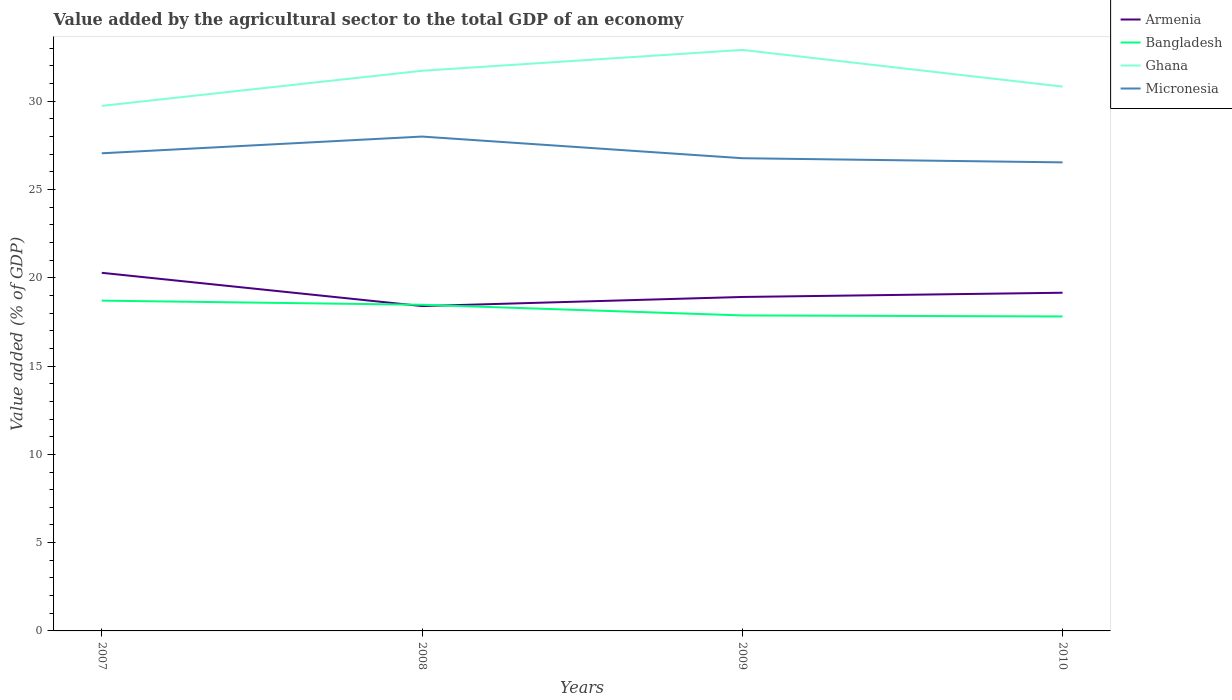How many different coloured lines are there?
Offer a very short reply. 4. Does the line corresponding to Armenia intersect with the line corresponding to Ghana?
Your answer should be compact. No. Across all years, what is the maximum value added by the agricultural sector to the total GDP in Micronesia?
Make the answer very short. 26.54. What is the total value added by the agricultural sector to the total GDP in Bangladesh in the graph?
Provide a succinct answer. 0.84. What is the difference between the highest and the second highest value added by the agricultural sector to the total GDP in Bangladesh?
Your answer should be compact. 0.9. What is the difference between the highest and the lowest value added by the agricultural sector to the total GDP in Armenia?
Keep it short and to the point. 1. Is the value added by the agricultural sector to the total GDP in Ghana strictly greater than the value added by the agricultural sector to the total GDP in Armenia over the years?
Provide a succinct answer. No. Are the values on the major ticks of Y-axis written in scientific E-notation?
Give a very brief answer. No. Where does the legend appear in the graph?
Offer a terse response. Top right. How many legend labels are there?
Ensure brevity in your answer.  4. How are the legend labels stacked?
Keep it short and to the point. Vertical. What is the title of the graph?
Keep it short and to the point. Value added by the agricultural sector to the total GDP of an economy. Does "Guinea-Bissau" appear as one of the legend labels in the graph?
Keep it short and to the point. No. What is the label or title of the X-axis?
Your response must be concise. Years. What is the label or title of the Y-axis?
Your response must be concise. Value added (% of GDP). What is the Value added (% of GDP) in Armenia in 2007?
Keep it short and to the point. 20.28. What is the Value added (% of GDP) of Bangladesh in 2007?
Provide a succinct answer. 18.71. What is the Value added (% of GDP) of Ghana in 2007?
Your answer should be very brief. 29.74. What is the Value added (% of GDP) of Micronesia in 2007?
Your response must be concise. 27.05. What is the Value added (% of GDP) of Armenia in 2008?
Your response must be concise. 18.4. What is the Value added (% of GDP) of Bangladesh in 2008?
Offer a terse response. 18.47. What is the Value added (% of GDP) in Ghana in 2008?
Your response must be concise. 31.72. What is the Value added (% of GDP) in Micronesia in 2008?
Give a very brief answer. 28. What is the Value added (% of GDP) of Armenia in 2009?
Ensure brevity in your answer.  18.91. What is the Value added (% of GDP) in Bangladesh in 2009?
Keep it short and to the point. 17.87. What is the Value added (% of GDP) of Ghana in 2009?
Offer a very short reply. 32.91. What is the Value added (% of GDP) in Micronesia in 2009?
Your answer should be very brief. 26.77. What is the Value added (% of GDP) of Armenia in 2010?
Keep it short and to the point. 19.15. What is the Value added (% of GDP) of Bangladesh in 2010?
Ensure brevity in your answer.  17.81. What is the Value added (% of GDP) of Ghana in 2010?
Your answer should be compact. 30.83. What is the Value added (% of GDP) in Micronesia in 2010?
Your response must be concise. 26.54. Across all years, what is the maximum Value added (% of GDP) in Armenia?
Offer a very short reply. 20.28. Across all years, what is the maximum Value added (% of GDP) of Bangladesh?
Ensure brevity in your answer.  18.71. Across all years, what is the maximum Value added (% of GDP) in Ghana?
Ensure brevity in your answer.  32.91. Across all years, what is the maximum Value added (% of GDP) of Micronesia?
Your answer should be compact. 28. Across all years, what is the minimum Value added (% of GDP) in Armenia?
Your response must be concise. 18.4. Across all years, what is the minimum Value added (% of GDP) of Bangladesh?
Your response must be concise. 17.81. Across all years, what is the minimum Value added (% of GDP) in Ghana?
Keep it short and to the point. 29.74. Across all years, what is the minimum Value added (% of GDP) of Micronesia?
Ensure brevity in your answer.  26.54. What is the total Value added (% of GDP) of Armenia in the graph?
Offer a terse response. 76.75. What is the total Value added (% of GDP) in Bangladesh in the graph?
Provide a succinct answer. 72.86. What is the total Value added (% of GDP) of Ghana in the graph?
Your response must be concise. 125.2. What is the total Value added (% of GDP) of Micronesia in the graph?
Your answer should be compact. 108.36. What is the difference between the Value added (% of GDP) in Armenia in 2007 and that in 2008?
Keep it short and to the point. 1.88. What is the difference between the Value added (% of GDP) of Bangladesh in 2007 and that in 2008?
Your answer should be very brief. 0.23. What is the difference between the Value added (% of GDP) in Ghana in 2007 and that in 2008?
Your response must be concise. -1.99. What is the difference between the Value added (% of GDP) in Micronesia in 2007 and that in 2008?
Provide a short and direct response. -0.95. What is the difference between the Value added (% of GDP) in Armenia in 2007 and that in 2009?
Offer a very short reply. 1.37. What is the difference between the Value added (% of GDP) in Bangladesh in 2007 and that in 2009?
Your response must be concise. 0.84. What is the difference between the Value added (% of GDP) of Ghana in 2007 and that in 2009?
Offer a very short reply. -3.17. What is the difference between the Value added (% of GDP) in Micronesia in 2007 and that in 2009?
Your answer should be compact. 0.28. What is the difference between the Value added (% of GDP) in Armenia in 2007 and that in 2010?
Give a very brief answer. 1.13. What is the difference between the Value added (% of GDP) in Bangladesh in 2007 and that in 2010?
Offer a terse response. 0.9. What is the difference between the Value added (% of GDP) of Ghana in 2007 and that in 2010?
Keep it short and to the point. -1.09. What is the difference between the Value added (% of GDP) in Micronesia in 2007 and that in 2010?
Provide a short and direct response. 0.52. What is the difference between the Value added (% of GDP) in Armenia in 2008 and that in 2009?
Give a very brief answer. -0.52. What is the difference between the Value added (% of GDP) of Bangladesh in 2008 and that in 2009?
Keep it short and to the point. 0.6. What is the difference between the Value added (% of GDP) in Ghana in 2008 and that in 2009?
Give a very brief answer. -1.18. What is the difference between the Value added (% of GDP) in Micronesia in 2008 and that in 2009?
Provide a succinct answer. 1.23. What is the difference between the Value added (% of GDP) of Armenia in 2008 and that in 2010?
Provide a succinct answer. -0.75. What is the difference between the Value added (% of GDP) of Bangladesh in 2008 and that in 2010?
Give a very brief answer. 0.66. What is the difference between the Value added (% of GDP) in Ghana in 2008 and that in 2010?
Keep it short and to the point. 0.9. What is the difference between the Value added (% of GDP) of Micronesia in 2008 and that in 2010?
Keep it short and to the point. 1.46. What is the difference between the Value added (% of GDP) in Armenia in 2009 and that in 2010?
Your response must be concise. -0.24. What is the difference between the Value added (% of GDP) of Bangladesh in 2009 and that in 2010?
Provide a short and direct response. 0.06. What is the difference between the Value added (% of GDP) in Ghana in 2009 and that in 2010?
Ensure brevity in your answer.  2.08. What is the difference between the Value added (% of GDP) of Micronesia in 2009 and that in 2010?
Your response must be concise. 0.24. What is the difference between the Value added (% of GDP) of Armenia in 2007 and the Value added (% of GDP) of Bangladesh in 2008?
Offer a very short reply. 1.81. What is the difference between the Value added (% of GDP) of Armenia in 2007 and the Value added (% of GDP) of Ghana in 2008?
Your answer should be compact. -11.44. What is the difference between the Value added (% of GDP) in Armenia in 2007 and the Value added (% of GDP) in Micronesia in 2008?
Provide a short and direct response. -7.72. What is the difference between the Value added (% of GDP) in Bangladesh in 2007 and the Value added (% of GDP) in Ghana in 2008?
Offer a very short reply. -13.02. What is the difference between the Value added (% of GDP) of Bangladesh in 2007 and the Value added (% of GDP) of Micronesia in 2008?
Offer a very short reply. -9.29. What is the difference between the Value added (% of GDP) in Ghana in 2007 and the Value added (% of GDP) in Micronesia in 2008?
Offer a very short reply. 1.74. What is the difference between the Value added (% of GDP) of Armenia in 2007 and the Value added (% of GDP) of Bangladesh in 2009?
Provide a succinct answer. 2.41. What is the difference between the Value added (% of GDP) of Armenia in 2007 and the Value added (% of GDP) of Ghana in 2009?
Provide a short and direct response. -12.62. What is the difference between the Value added (% of GDP) of Armenia in 2007 and the Value added (% of GDP) of Micronesia in 2009?
Provide a succinct answer. -6.49. What is the difference between the Value added (% of GDP) of Bangladesh in 2007 and the Value added (% of GDP) of Ghana in 2009?
Your answer should be very brief. -14.2. What is the difference between the Value added (% of GDP) in Bangladesh in 2007 and the Value added (% of GDP) in Micronesia in 2009?
Keep it short and to the point. -8.07. What is the difference between the Value added (% of GDP) in Ghana in 2007 and the Value added (% of GDP) in Micronesia in 2009?
Offer a terse response. 2.97. What is the difference between the Value added (% of GDP) of Armenia in 2007 and the Value added (% of GDP) of Bangladesh in 2010?
Offer a very short reply. 2.47. What is the difference between the Value added (% of GDP) of Armenia in 2007 and the Value added (% of GDP) of Ghana in 2010?
Your answer should be compact. -10.55. What is the difference between the Value added (% of GDP) in Armenia in 2007 and the Value added (% of GDP) in Micronesia in 2010?
Offer a very short reply. -6.25. What is the difference between the Value added (% of GDP) in Bangladesh in 2007 and the Value added (% of GDP) in Ghana in 2010?
Your answer should be compact. -12.12. What is the difference between the Value added (% of GDP) in Bangladesh in 2007 and the Value added (% of GDP) in Micronesia in 2010?
Your answer should be compact. -7.83. What is the difference between the Value added (% of GDP) of Ghana in 2007 and the Value added (% of GDP) of Micronesia in 2010?
Give a very brief answer. 3.2. What is the difference between the Value added (% of GDP) in Armenia in 2008 and the Value added (% of GDP) in Bangladesh in 2009?
Make the answer very short. 0.53. What is the difference between the Value added (% of GDP) of Armenia in 2008 and the Value added (% of GDP) of Ghana in 2009?
Provide a short and direct response. -14.51. What is the difference between the Value added (% of GDP) in Armenia in 2008 and the Value added (% of GDP) in Micronesia in 2009?
Ensure brevity in your answer.  -8.37. What is the difference between the Value added (% of GDP) of Bangladesh in 2008 and the Value added (% of GDP) of Ghana in 2009?
Provide a succinct answer. -14.43. What is the difference between the Value added (% of GDP) in Bangladesh in 2008 and the Value added (% of GDP) in Micronesia in 2009?
Ensure brevity in your answer.  -8.3. What is the difference between the Value added (% of GDP) in Ghana in 2008 and the Value added (% of GDP) in Micronesia in 2009?
Your answer should be compact. 4.95. What is the difference between the Value added (% of GDP) of Armenia in 2008 and the Value added (% of GDP) of Bangladesh in 2010?
Ensure brevity in your answer.  0.59. What is the difference between the Value added (% of GDP) of Armenia in 2008 and the Value added (% of GDP) of Ghana in 2010?
Keep it short and to the point. -12.43. What is the difference between the Value added (% of GDP) in Armenia in 2008 and the Value added (% of GDP) in Micronesia in 2010?
Your answer should be compact. -8.14. What is the difference between the Value added (% of GDP) of Bangladesh in 2008 and the Value added (% of GDP) of Ghana in 2010?
Provide a succinct answer. -12.36. What is the difference between the Value added (% of GDP) in Bangladesh in 2008 and the Value added (% of GDP) in Micronesia in 2010?
Offer a terse response. -8.06. What is the difference between the Value added (% of GDP) in Ghana in 2008 and the Value added (% of GDP) in Micronesia in 2010?
Provide a short and direct response. 5.19. What is the difference between the Value added (% of GDP) of Armenia in 2009 and the Value added (% of GDP) of Bangladesh in 2010?
Keep it short and to the point. 1.1. What is the difference between the Value added (% of GDP) of Armenia in 2009 and the Value added (% of GDP) of Ghana in 2010?
Your answer should be compact. -11.91. What is the difference between the Value added (% of GDP) of Armenia in 2009 and the Value added (% of GDP) of Micronesia in 2010?
Provide a succinct answer. -7.62. What is the difference between the Value added (% of GDP) of Bangladesh in 2009 and the Value added (% of GDP) of Ghana in 2010?
Give a very brief answer. -12.96. What is the difference between the Value added (% of GDP) in Bangladesh in 2009 and the Value added (% of GDP) in Micronesia in 2010?
Offer a very short reply. -8.67. What is the difference between the Value added (% of GDP) of Ghana in 2009 and the Value added (% of GDP) of Micronesia in 2010?
Ensure brevity in your answer.  6.37. What is the average Value added (% of GDP) in Armenia per year?
Give a very brief answer. 19.19. What is the average Value added (% of GDP) of Bangladesh per year?
Your answer should be very brief. 18.21. What is the average Value added (% of GDP) of Ghana per year?
Give a very brief answer. 31.3. What is the average Value added (% of GDP) in Micronesia per year?
Ensure brevity in your answer.  27.09. In the year 2007, what is the difference between the Value added (% of GDP) of Armenia and Value added (% of GDP) of Bangladesh?
Keep it short and to the point. 1.58. In the year 2007, what is the difference between the Value added (% of GDP) of Armenia and Value added (% of GDP) of Ghana?
Provide a succinct answer. -9.46. In the year 2007, what is the difference between the Value added (% of GDP) in Armenia and Value added (% of GDP) in Micronesia?
Your response must be concise. -6.77. In the year 2007, what is the difference between the Value added (% of GDP) in Bangladesh and Value added (% of GDP) in Ghana?
Provide a short and direct response. -11.03. In the year 2007, what is the difference between the Value added (% of GDP) in Bangladesh and Value added (% of GDP) in Micronesia?
Give a very brief answer. -8.35. In the year 2007, what is the difference between the Value added (% of GDP) of Ghana and Value added (% of GDP) of Micronesia?
Provide a succinct answer. 2.69. In the year 2008, what is the difference between the Value added (% of GDP) in Armenia and Value added (% of GDP) in Bangladesh?
Offer a very short reply. -0.07. In the year 2008, what is the difference between the Value added (% of GDP) of Armenia and Value added (% of GDP) of Ghana?
Provide a succinct answer. -13.33. In the year 2008, what is the difference between the Value added (% of GDP) in Armenia and Value added (% of GDP) in Micronesia?
Your response must be concise. -9.6. In the year 2008, what is the difference between the Value added (% of GDP) of Bangladesh and Value added (% of GDP) of Ghana?
Make the answer very short. -13.25. In the year 2008, what is the difference between the Value added (% of GDP) of Bangladesh and Value added (% of GDP) of Micronesia?
Ensure brevity in your answer.  -9.53. In the year 2008, what is the difference between the Value added (% of GDP) in Ghana and Value added (% of GDP) in Micronesia?
Make the answer very short. 3.73. In the year 2009, what is the difference between the Value added (% of GDP) of Armenia and Value added (% of GDP) of Bangladesh?
Ensure brevity in your answer.  1.05. In the year 2009, what is the difference between the Value added (% of GDP) in Armenia and Value added (% of GDP) in Ghana?
Make the answer very short. -13.99. In the year 2009, what is the difference between the Value added (% of GDP) in Armenia and Value added (% of GDP) in Micronesia?
Keep it short and to the point. -7.86. In the year 2009, what is the difference between the Value added (% of GDP) of Bangladesh and Value added (% of GDP) of Ghana?
Offer a terse response. -15.04. In the year 2009, what is the difference between the Value added (% of GDP) in Bangladesh and Value added (% of GDP) in Micronesia?
Give a very brief answer. -8.9. In the year 2009, what is the difference between the Value added (% of GDP) of Ghana and Value added (% of GDP) of Micronesia?
Your answer should be very brief. 6.13. In the year 2010, what is the difference between the Value added (% of GDP) in Armenia and Value added (% of GDP) in Bangladesh?
Provide a short and direct response. 1.34. In the year 2010, what is the difference between the Value added (% of GDP) in Armenia and Value added (% of GDP) in Ghana?
Your response must be concise. -11.68. In the year 2010, what is the difference between the Value added (% of GDP) of Armenia and Value added (% of GDP) of Micronesia?
Your answer should be very brief. -7.38. In the year 2010, what is the difference between the Value added (% of GDP) of Bangladesh and Value added (% of GDP) of Ghana?
Provide a succinct answer. -13.02. In the year 2010, what is the difference between the Value added (% of GDP) in Bangladesh and Value added (% of GDP) in Micronesia?
Keep it short and to the point. -8.73. In the year 2010, what is the difference between the Value added (% of GDP) in Ghana and Value added (% of GDP) in Micronesia?
Your answer should be very brief. 4.29. What is the ratio of the Value added (% of GDP) of Armenia in 2007 to that in 2008?
Make the answer very short. 1.1. What is the ratio of the Value added (% of GDP) of Bangladesh in 2007 to that in 2008?
Make the answer very short. 1.01. What is the ratio of the Value added (% of GDP) in Ghana in 2007 to that in 2008?
Your answer should be very brief. 0.94. What is the ratio of the Value added (% of GDP) in Micronesia in 2007 to that in 2008?
Provide a succinct answer. 0.97. What is the ratio of the Value added (% of GDP) of Armenia in 2007 to that in 2009?
Provide a short and direct response. 1.07. What is the ratio of the Value added (% of GDP) of Bangladesh in 2007 to that in 2009?
Your response must be concise. 1.05. What is the ratio of the Value added (% of GDP) in Ghana in 2007 to that in 2009?
Give a very brief answer. 0.9. What is the ratio of the Value added (% of GDP) of Micronesia in 2007 to that in 2009?
Keep it short and to the point. 1.01. What is the ratio of the Value added (% of GDP) in Armenia in 2007 to that in 2010?
Make the answer very short. 1.06. What is the ratio of the Value added (% of GDP) in Bangladesh in 2007 to that in 2010?
Offer a very short reply. 1.05. What is the ratio of the Value added (% of GDP) of Ghana in 2007 to that in 2010?
Your response must be concise. 0.96. What is the ratio of the Value added (% of GDP) in Micronesia in 2007 to that in 2010?
Keep it short and to the point. 1.02. What is the ratio of the Value added (% of GDP) in Armenia in 2008 to that in 2009?
Your response must be concise. 0.97. What is the ratio of the Value added (% of GDP) of Bangladesh in 2008 to that in 2009?
Offer a terse response. 1.03. What is the ratio of the Value added (% of GDP) in Ghana in 2008 to that in 2009?
Offer a very short reply. 0.96. What is the ratio of the Value added (% of GDP) of Micronesia in 2008 to that in 2009?
Offer a terse response. 1.05. What is the ratio of the Value added (% of GDP) of Armenia in 2008 to that in 2010?
Offer a very short reply. 0.96. What is the ratio of the Value added (% of GDP) in Bangladesh in 2008 to that in 2010?
Give a very brief answer. 1.04. What is the ratio of the Value added (% of GDP) of Ghana in 2008 to that in 2010?
Your answer should be very brief. 1.03. What is the ratio of the Value added (% of GDP) of Micronesia in 2008 to that in 2010?
Ensure brevity in your answer.  1.06. What is the ratio of the Value added (% of GDP) in Armenia in 2009 to that in 2010?
Ensure brevity in your answer.  0.99. What is the ratio of the Value added (% of GDP) of Bangladesh in 2009 to that in 2010?
Make the answer very short. 1. What is the ratio of the Value added (% of GDP) of Ghana in 2009 to that in 2010?
Offer a terse response. 1.07. What is the ratio of the Value added (% of GDP) in Micronesia in 2009 to that in 2010?
Offer a very short reply. 1.01. What is the difference between the highest and the second highest Value added (% of GDP) of Armenia?
Ensure brevity in your answer.  1.13. What is the difference between the highest and the second highest Value added (% of GDP) in Bangladesh?
Give a very brief answer. 0.23. What is the difference between the highest and the second highest Value added (% of GDP) in Ghana?
Your answer should be very brief. 1.18. What is the difference between the highest and the second highest Value added (% of GDP) in Micronesia?
Ensure brevity in your answer.  0.95. What is the difference between the highest and the lowest Value added (% of GDP) of Armenia?
Offer a very short reply. 1.88. What is the difference between the highest and the lowest Value added (% of GDP) in Bangladesh?
Your answer should be compact. 0.9. What is the difference between the highest and the lowest Value added (% of GDP) in Ghana?
Make the answer very short. 3.17. What is the difference between the highest and the lowest Value added (% of GDP) in Micronesia?
Ensure brevity in your answer.  1.46. 